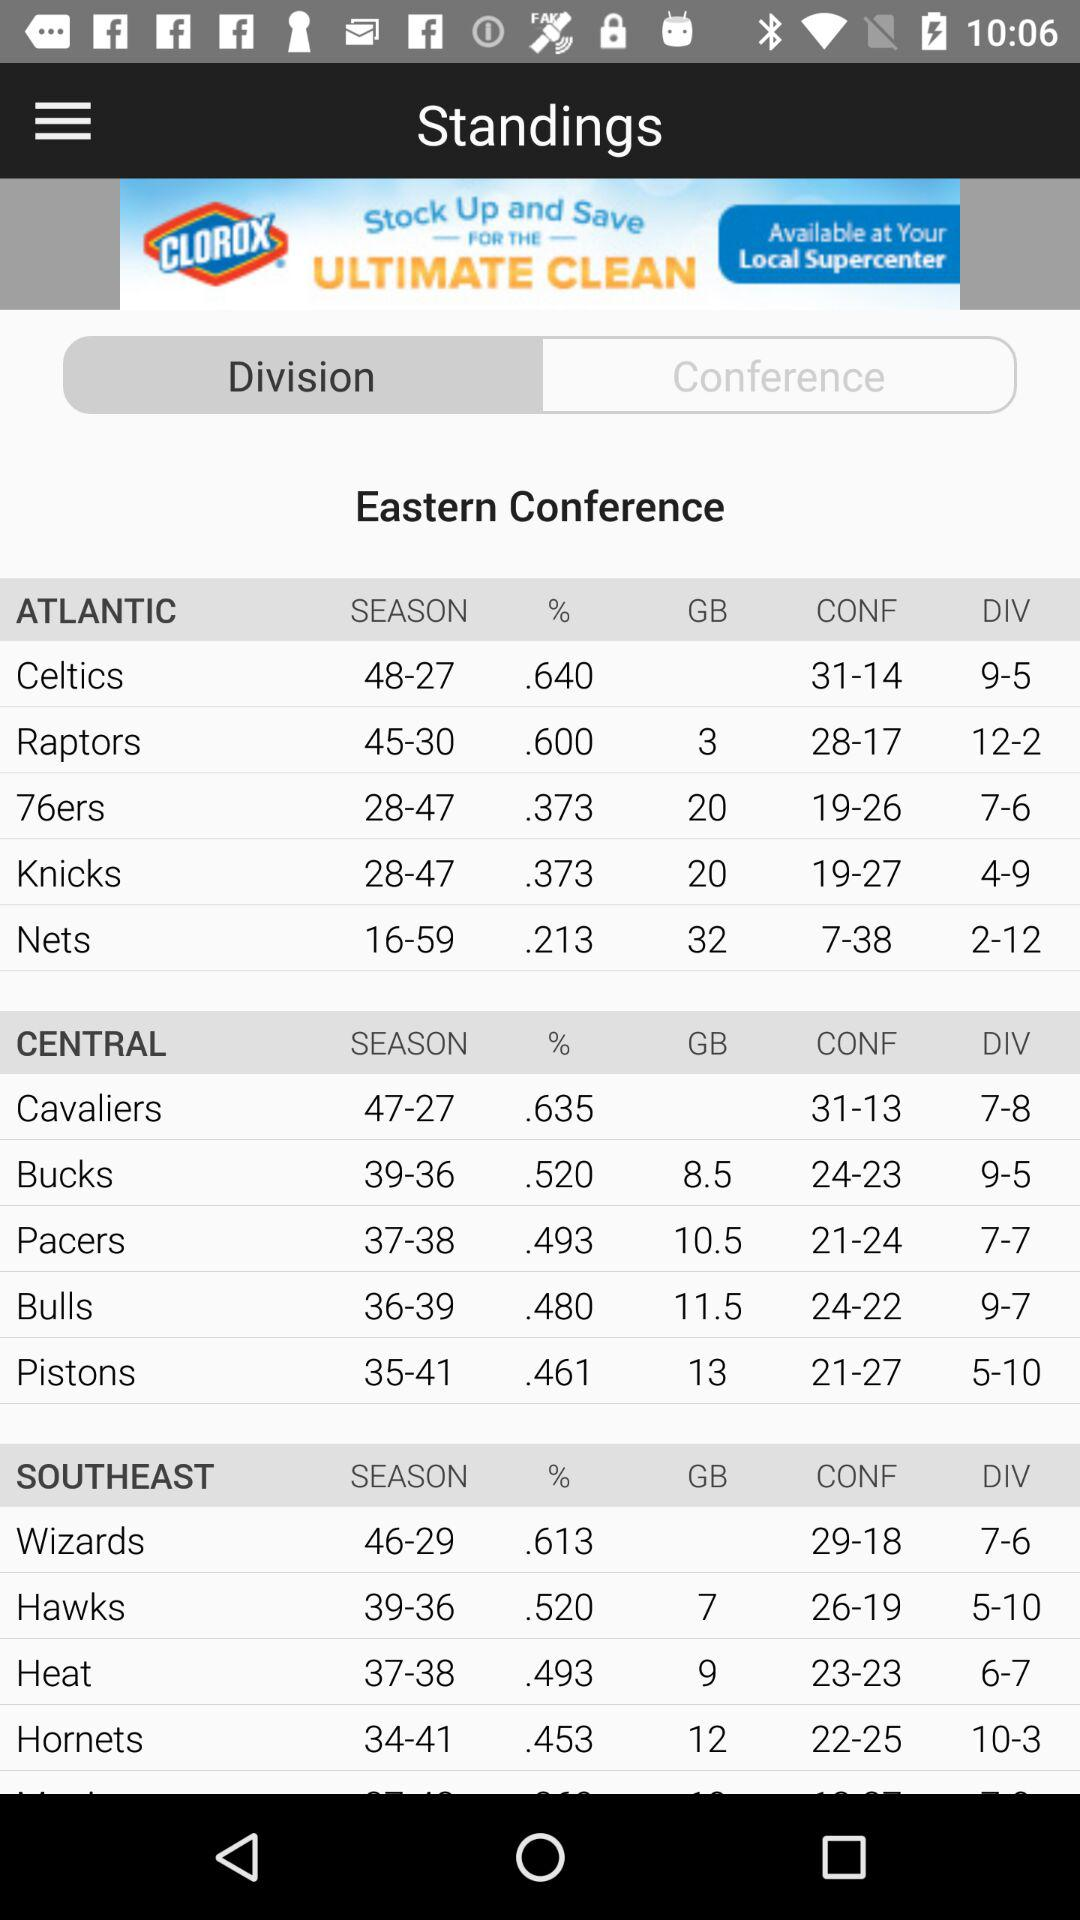What is the division of "76ers"? The division is 7-6. 